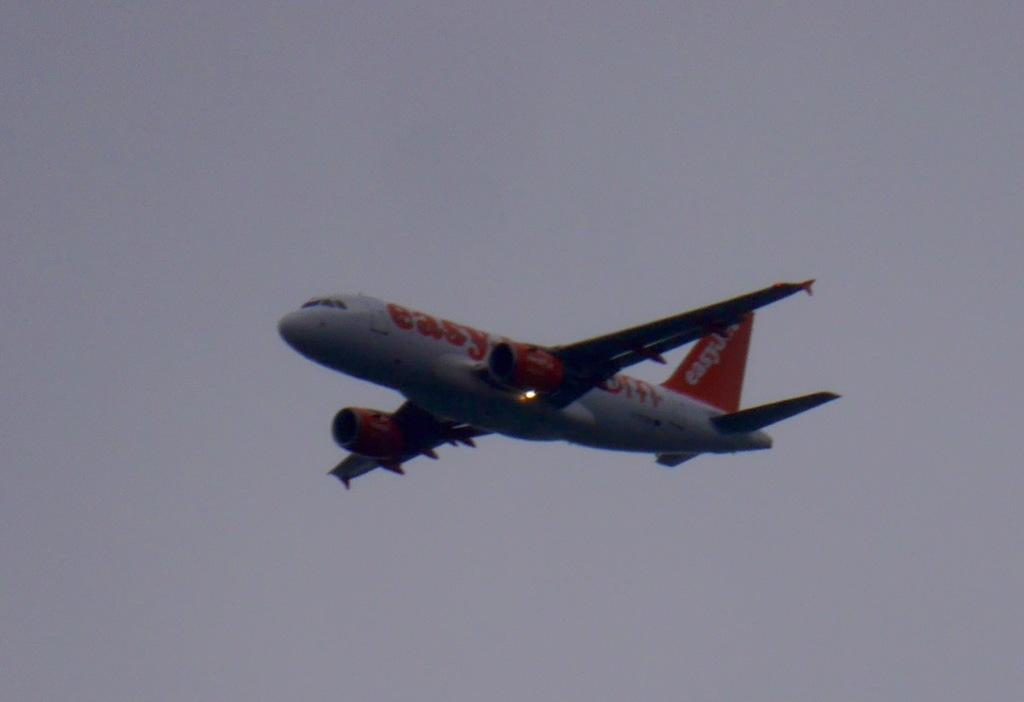What is the main subject of the image? The main subject of the image is an aeroplane. What is the aeroplane doing in the image? The aeroplane is flying in the air. What can be seen in the background of the image? The sky is visible in the background of the image. What language is the frog speaking in the image? There is no frog present in the image, and therefore no such activity can be observed. 